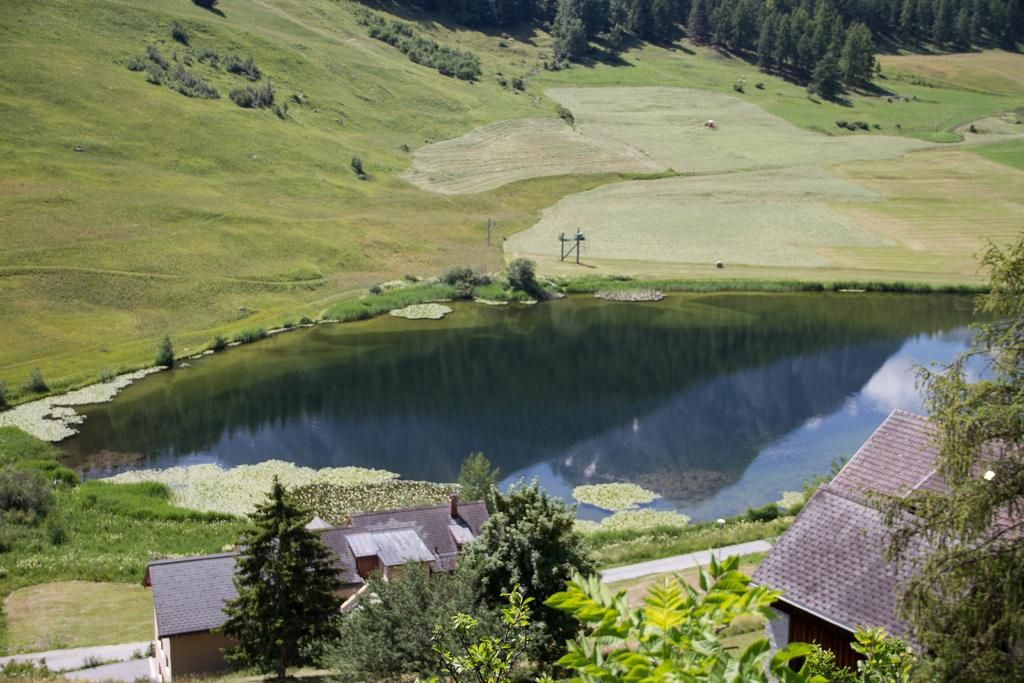What can be seen in the foreground of the image? There are two houses and trees in the foreground of the image. What is visible in the background of the image? There is a lake, grass, trees, plants, and poles in the background of the image. How many houses are present in the image? There are two houses in the image. What type of card is being used to build the brick wall in the image? There is no card or brick wall present in the image. How many cherries are hanging from the trees in the image? There are no cherries visible in the image; only trees, plants, and poles are present in the background. 